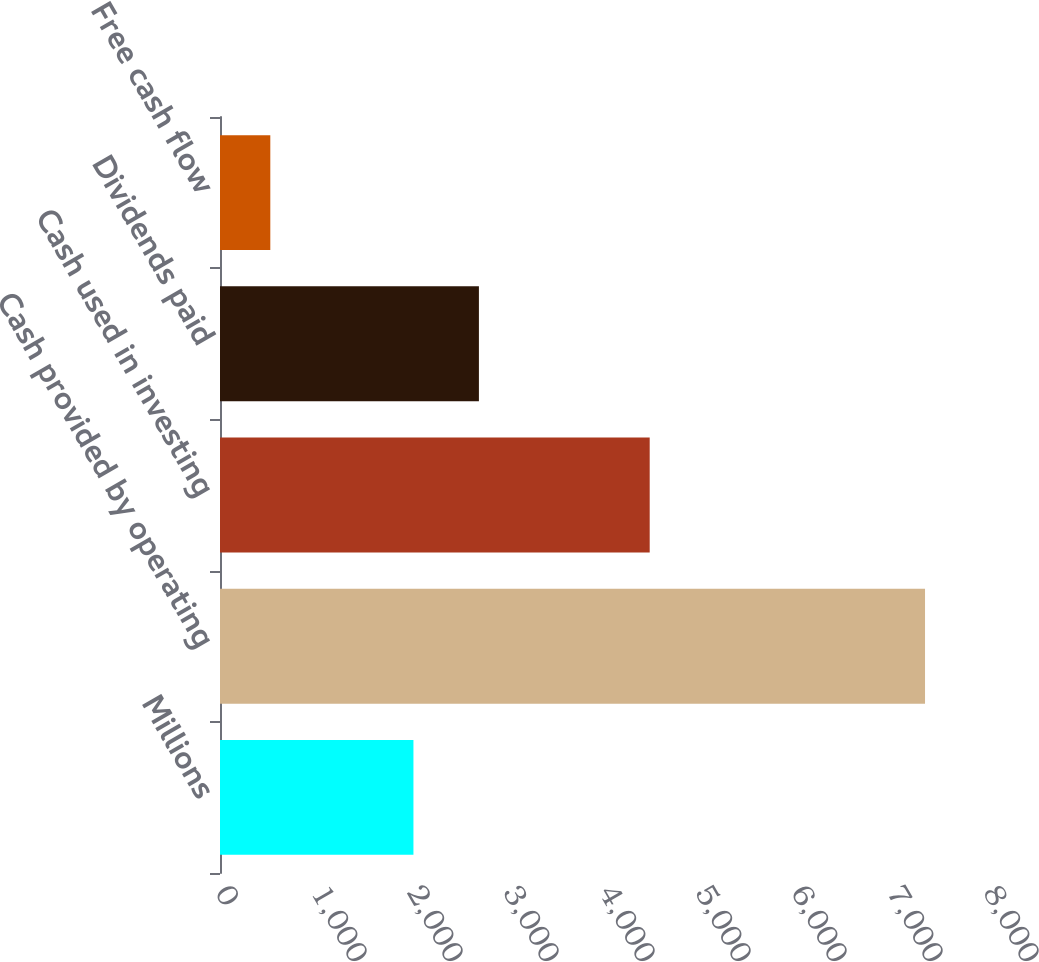<chart> <loc_0><loc_0><loc_500><loc_500><bar_chart><fcel>Millions<fcel>Cash provided by operating<fcel>Cash used in investing<fcel>Dividends paid<fcel>Free cash flow<nl><fcel>2015<fcel>7344<fcel>4476<fcel>2697<fcel>524<nl></chart> 